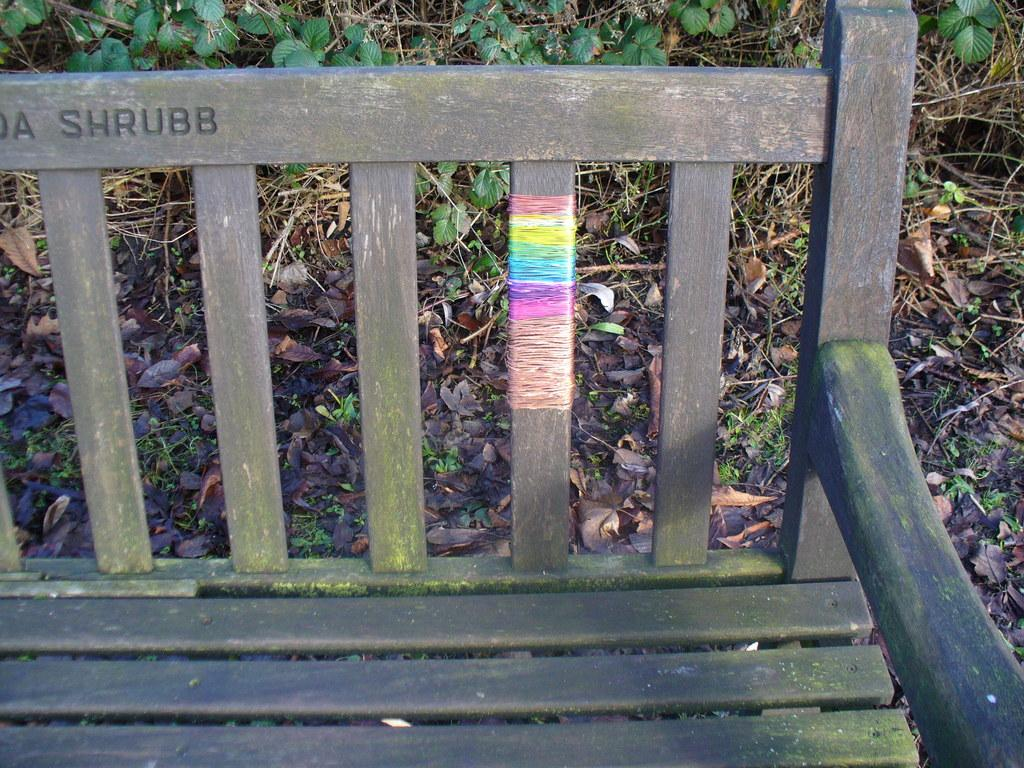What type of seating is visible in the image? There is a bench in the image. What can be seen in the background of the image? There are plants and twigs in the background of the image. What type of book is the fowl reading in the image? There is no book or fowl present in the image. Is there any snow visible in the image? No, there is no snow present in the image. 